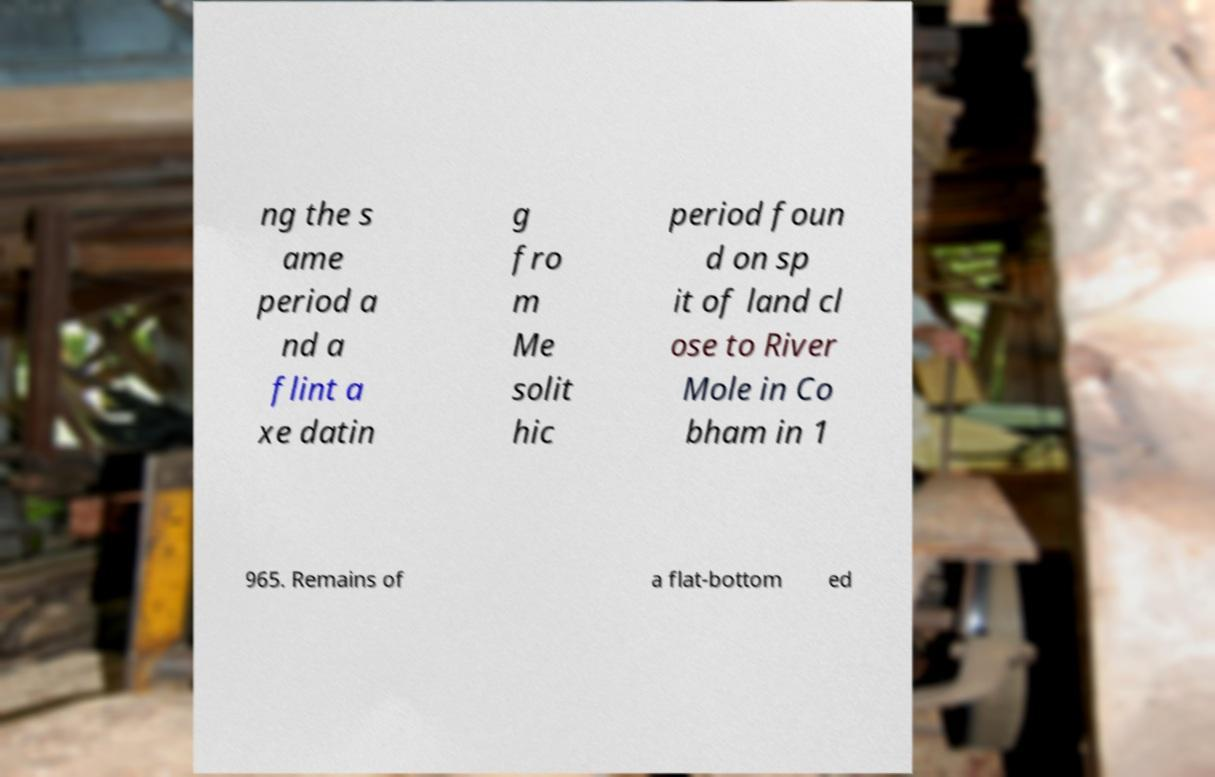There's text embedded in this image that I need extracted. Can you transcribe it verbatim? ng the s ame period a nd a flint a xe datin g fro m Me solit hic period foun d on sp it of land cl ose to River Mole in Co bham in 1 965. Remains of a flat-bottom ed 